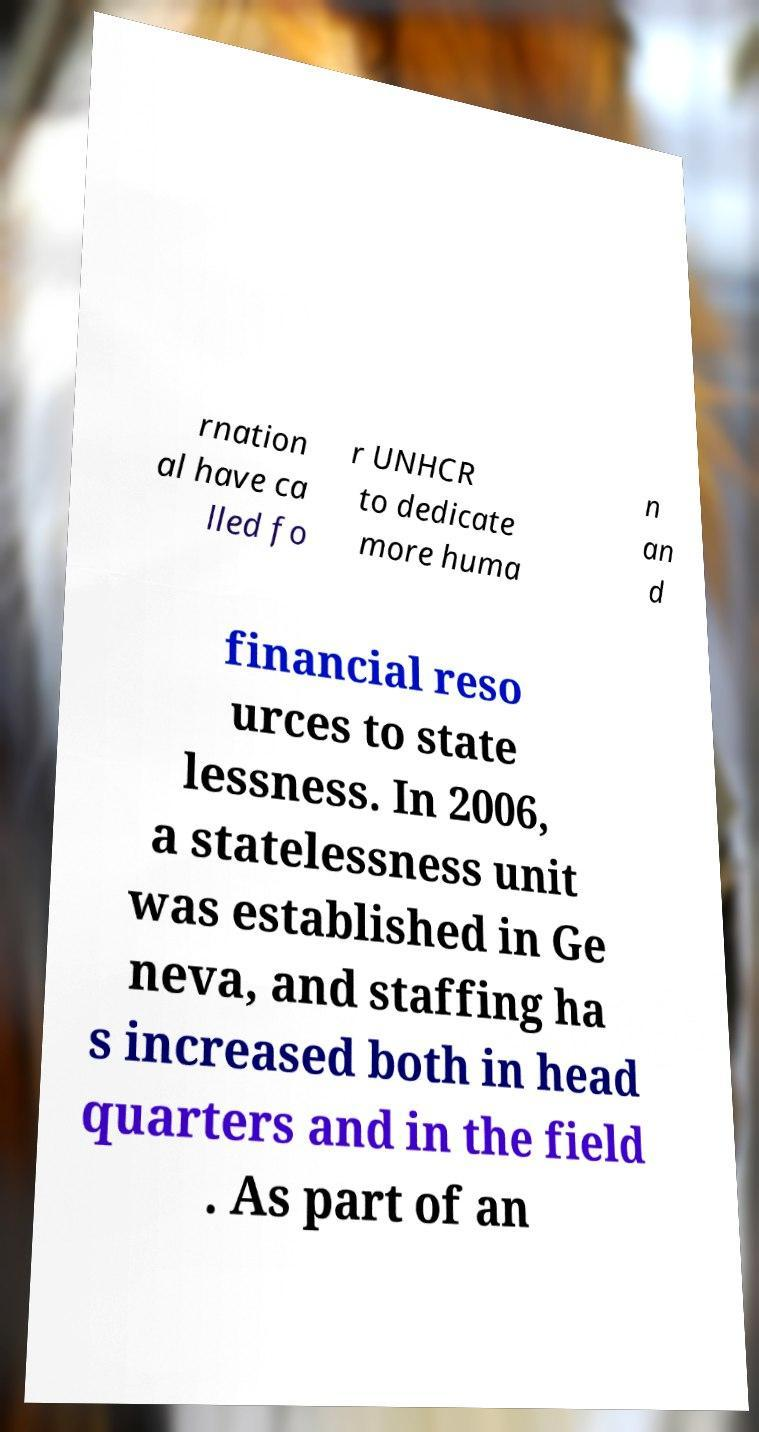What messages or text are displayed in this image? I need them in a readable, typed format. rnation al have ca lled fo r UNHCR to dedicate more huma n an d financial reso urces to state lessness. In 2006, a statelessness unit was established in Ge neva, and staffing ha s increased both in head quarters and in the field . As part of an 